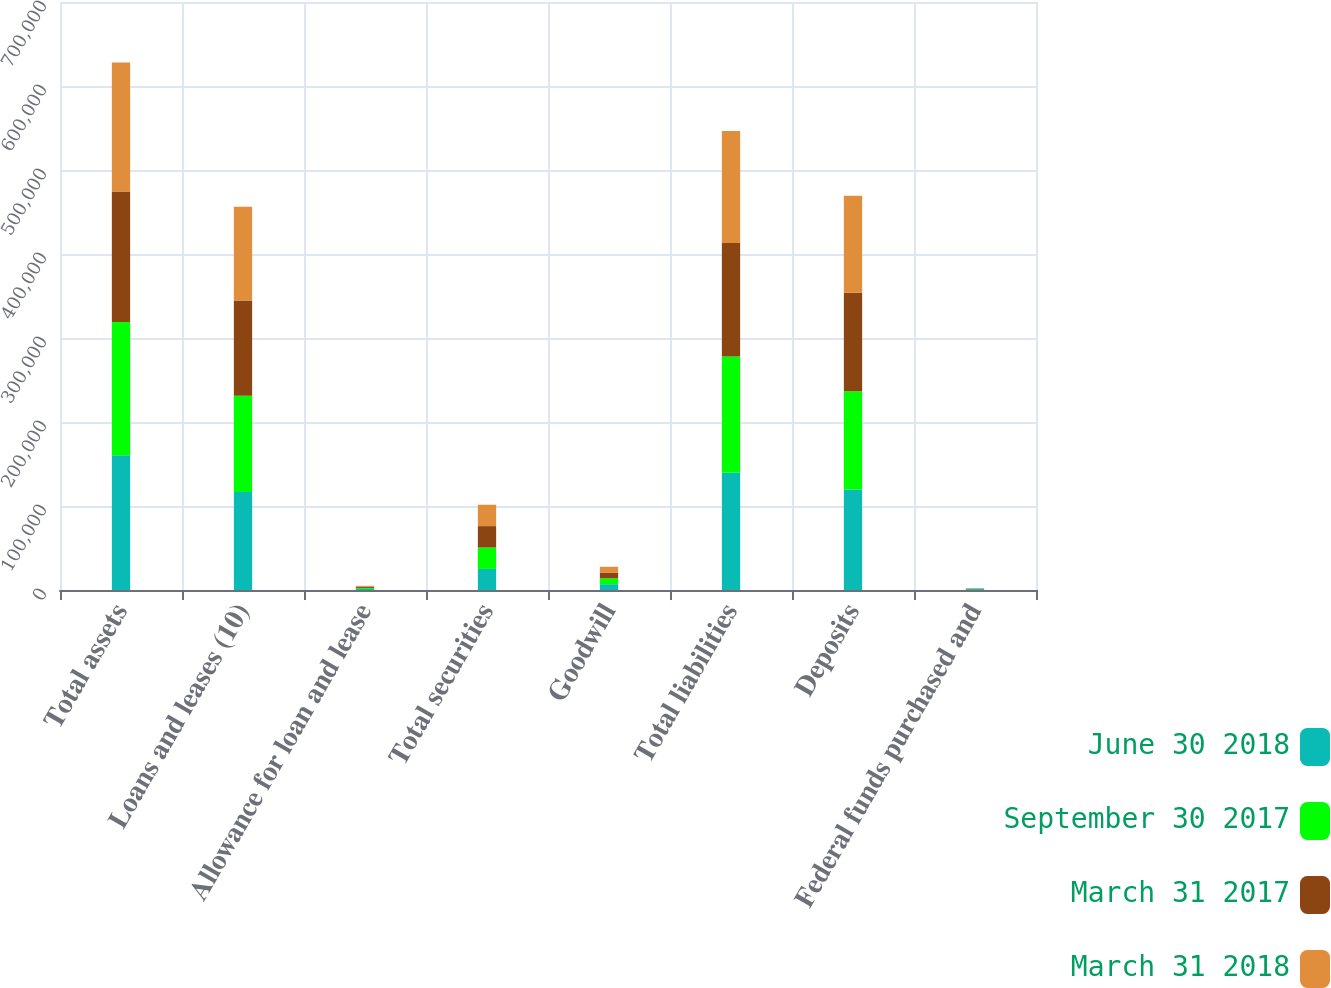<chart> <loc_0><loc_0><loc_500><loc_500><stacked_bar_chart><ecel><fcel>Total assets<fcel>Loans and leases (10)<fcel>Allowance for loan and lease<fcel>Total securities<fcel>Goodwill<fcel>Total liabilities<fcel>Deposits<fcel>Federal funds purchased and<nl><fcel>June 30 2018<fcel>160518<fcel>116660<fcel>1242<fcel>25075<fcel>6923<fcel>139701<fcel>119575<fcel>1156<nl><fcel>September 30 2017<fcel>158598<fcel>114720<fcel>1242<fcel>25485<fcel>6946<fcel>138322<fcel>117075<fcel>374<nl><fcel>March 31 2017<fcel>155431<fcel>113407<fcel>1253<fcel>25513<fcel>6887<fcel>134964<fcel>117073<fcel>326<nl><fcel>March 31 2018<fcel>153453<fcel>111425<fcel>1246<fcel>25433<fcel>6887<fcel>133394<fcel>115730<fcel>315<nl></chart> 